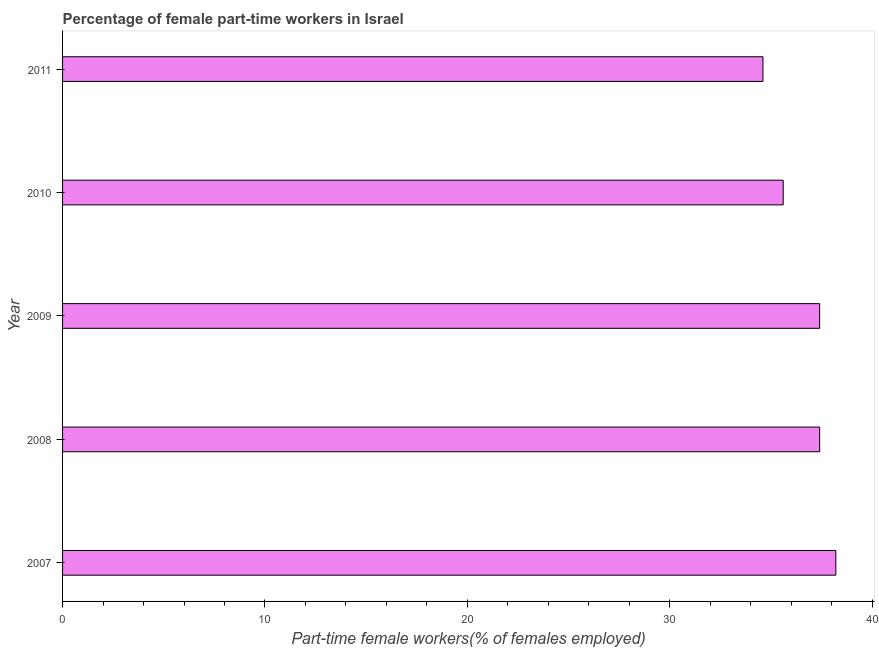Does the graph contain grids?
Give a very brief answer. No. What is the title of the graph?
Ensure brevity in your answer.  Percentage of female part-time workers in Israel. What is the label or title of the X-axis?
Offer a very short reply. Part-time female workers(% of females employed). What is the percentage of part-time female workers in 2010?
Your response must be concise. 35.6. Across all years, what is the maximum percentage of part-time female workers?
Provide a short and direct response. 38.2. Across all years, what is the minimum percentage of part-time female workers?
Keep it short and to the point. 34.6. What is the sum of the percentage of part-time female workers?
Your answer should be very brief. 183.2. What is the difference between the percentage of part-time female workers in 2007 and 2009?
Make the answer very short. 0.8. What is the average percentage of part-time female workers per year?
Your response must be concise. 36.64. What is the median percentage of part-time female workers?
Ensure brevity in your answer.  37.4. In how many years, is the percentage of part-time female workers greater than 2 %?
Your answer should be very brief. 5. Do a majority of the years between 2009 and 2011 (inclusive) have percentage of part-time female workers greater than 20 %?
Provide a succinct answer. Yes. What is the ratio of the percentage of part-time female workers in 2007 to that in 2010?
Give a very brief answer. 1.07. Is the difference between the percentage of part-time female workers in 2007 and 2010 greater than the difference between any two years?
Keep it short and to the point. No. What is the difference between the highest and the second highest percentage of part-time female workers?
Your response must be concise. 0.8. Is the sum of the percentage of part-time female workers in 2008 and 2010 greater than the maximum percentage of part-time female workers across all years?
Make the answer very short. Yes. Are all the bars in the graph horizontal?
Give a very brief answer. Yes. What is the difference between two consecutive major ticks on the X-axis?
Provide a succinct answer. 10. Are the values on the major ticks of X-axis written in scientific E-notation?
Give a very brief answer. No. What is the Part-time female workers(% of females employed) in 2007?
Offer a very short reply. 38.2. What is the Part-time female workers(% of females employed) in 2008?
Your answer should be compact. 37.4. What is the Part-time female workers(% of females employed) in 2009?
Keep it short and to the point. 37.4. What is the Part-time female workers(% of females employed) of 2010?
Provide a short and direct response. 35.6. What is the Part-time female workers(% of females employed) of 2011?
Keep it short and to the point. 34.6. What is the difference between the Part-time female workers(% of females employed) in 2007 and 2009?
Your answer should be compact. 0.8. What is the difference between the Part-time female workers(% of females employed) in 2008 and 2009?
Offer a terse response. 0. What is the difference between the Part-time female workers(% of females employed) in 2008 and 2010?
Your answer should be very brief. 1.8. What is the difference between the Part-time female workers(% of females employed) in 2008 and 2011?
Ensure brevity in your answer.  2.8. What is the difference between the Part-time female workers(% of females employed) in 2009 and 2011?
Give a very brief answer. 2.8. What is the ratio of the Part-time female workers(% of females employed) in 2007 to that in 2010?
Keep it short and to the point. 1.07. What is the ratio of the Part-time female workers(% of females employed) in 2007 to that in 2011?
Your answer should be very brief. 1.1. What is the ratio of the Part-time female workers(% of females employed) in 2008 to that in 2009?
Your response must be concise. 1. What is the ratio of the Part-time female workers(% of females employed) in 2008 to that in 2010?
Provide a short and direct response. 1.05. What is the ratio of the Part-time female workers(% of females employed) in 2008 to that in 2011?
Your response must be concise. 1.08. What is the ratio of the Part-time female workers(% of females employed) in 2009 to that in 2010?
Give a very brief answer. 1.05. What is the ratio of the Part-time female workers(% of females employed) in 2009 to that in 2011?
Your response must be concise. 1.08. What is the ratio of the Part-time female workers(% of females employed) in 2010 to that in 2011?
Offer a very short reply. 1.03. 